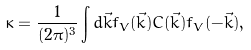<formula> <loc_0><loc_0><loc_500><loc_500>\kappa = \frac { 1 } { ( 2 \pi ) ^ { 3 } } \int { d \vec { k } f _ { V } ( \vec { k } ) C ( \vec { k } ) f _ { V } ( - \vec { k } ) } ,</formula> 